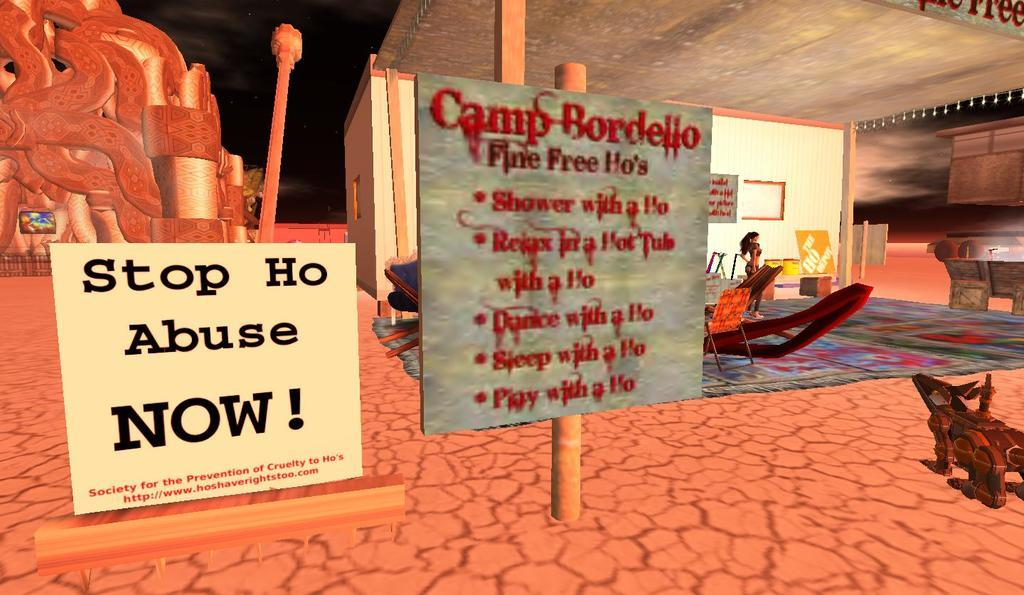<image>
Share a concise interpretation of the image provided. A screenshot of a video game with a sign that says Stop Ho Abuse. 